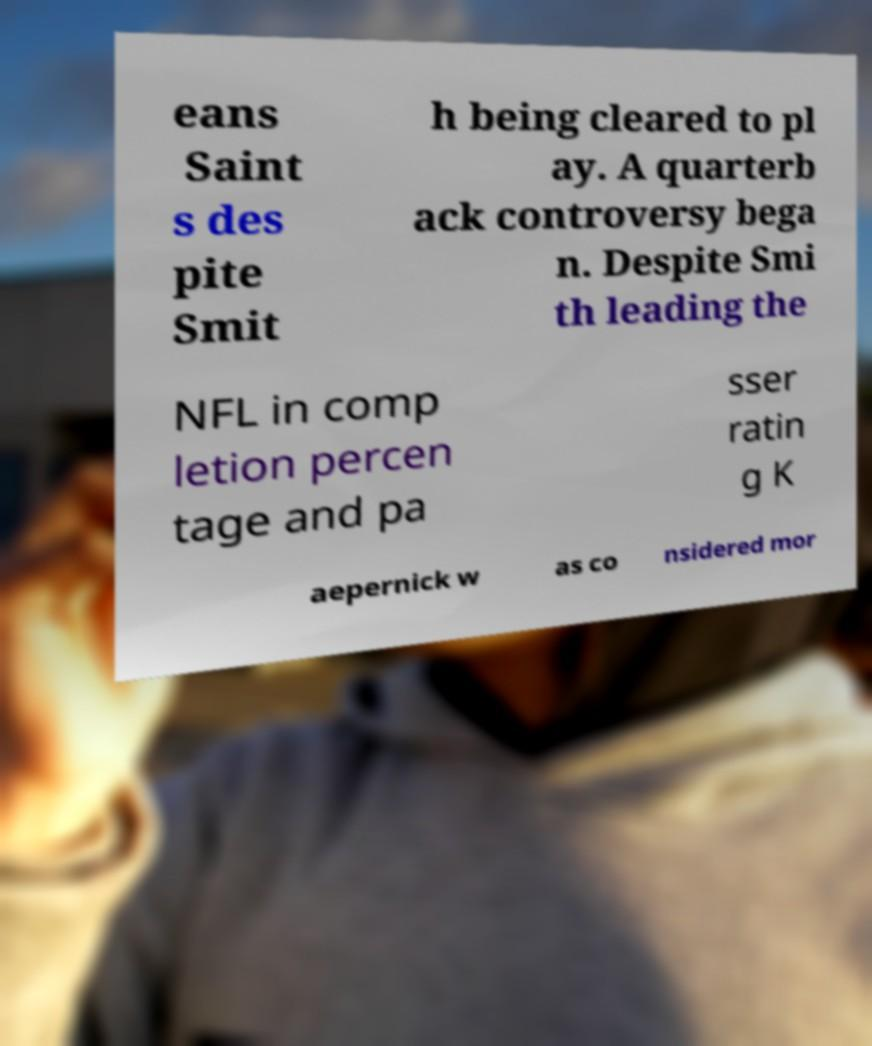Can you read and provide the text displayed in the image?This photo seems to have some interesting text. Can you extract and type it out for me? eans Saint s des pite Smit h being cleared to pl ay. A quarterb ack controversy bega n. Despite Smi th leading the NFL in comp letion percen tage and pa sser ratin g K aepernick w as co nsidered mor 